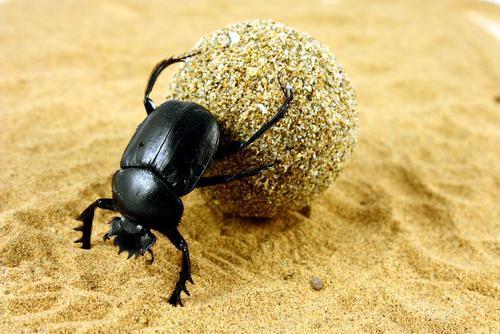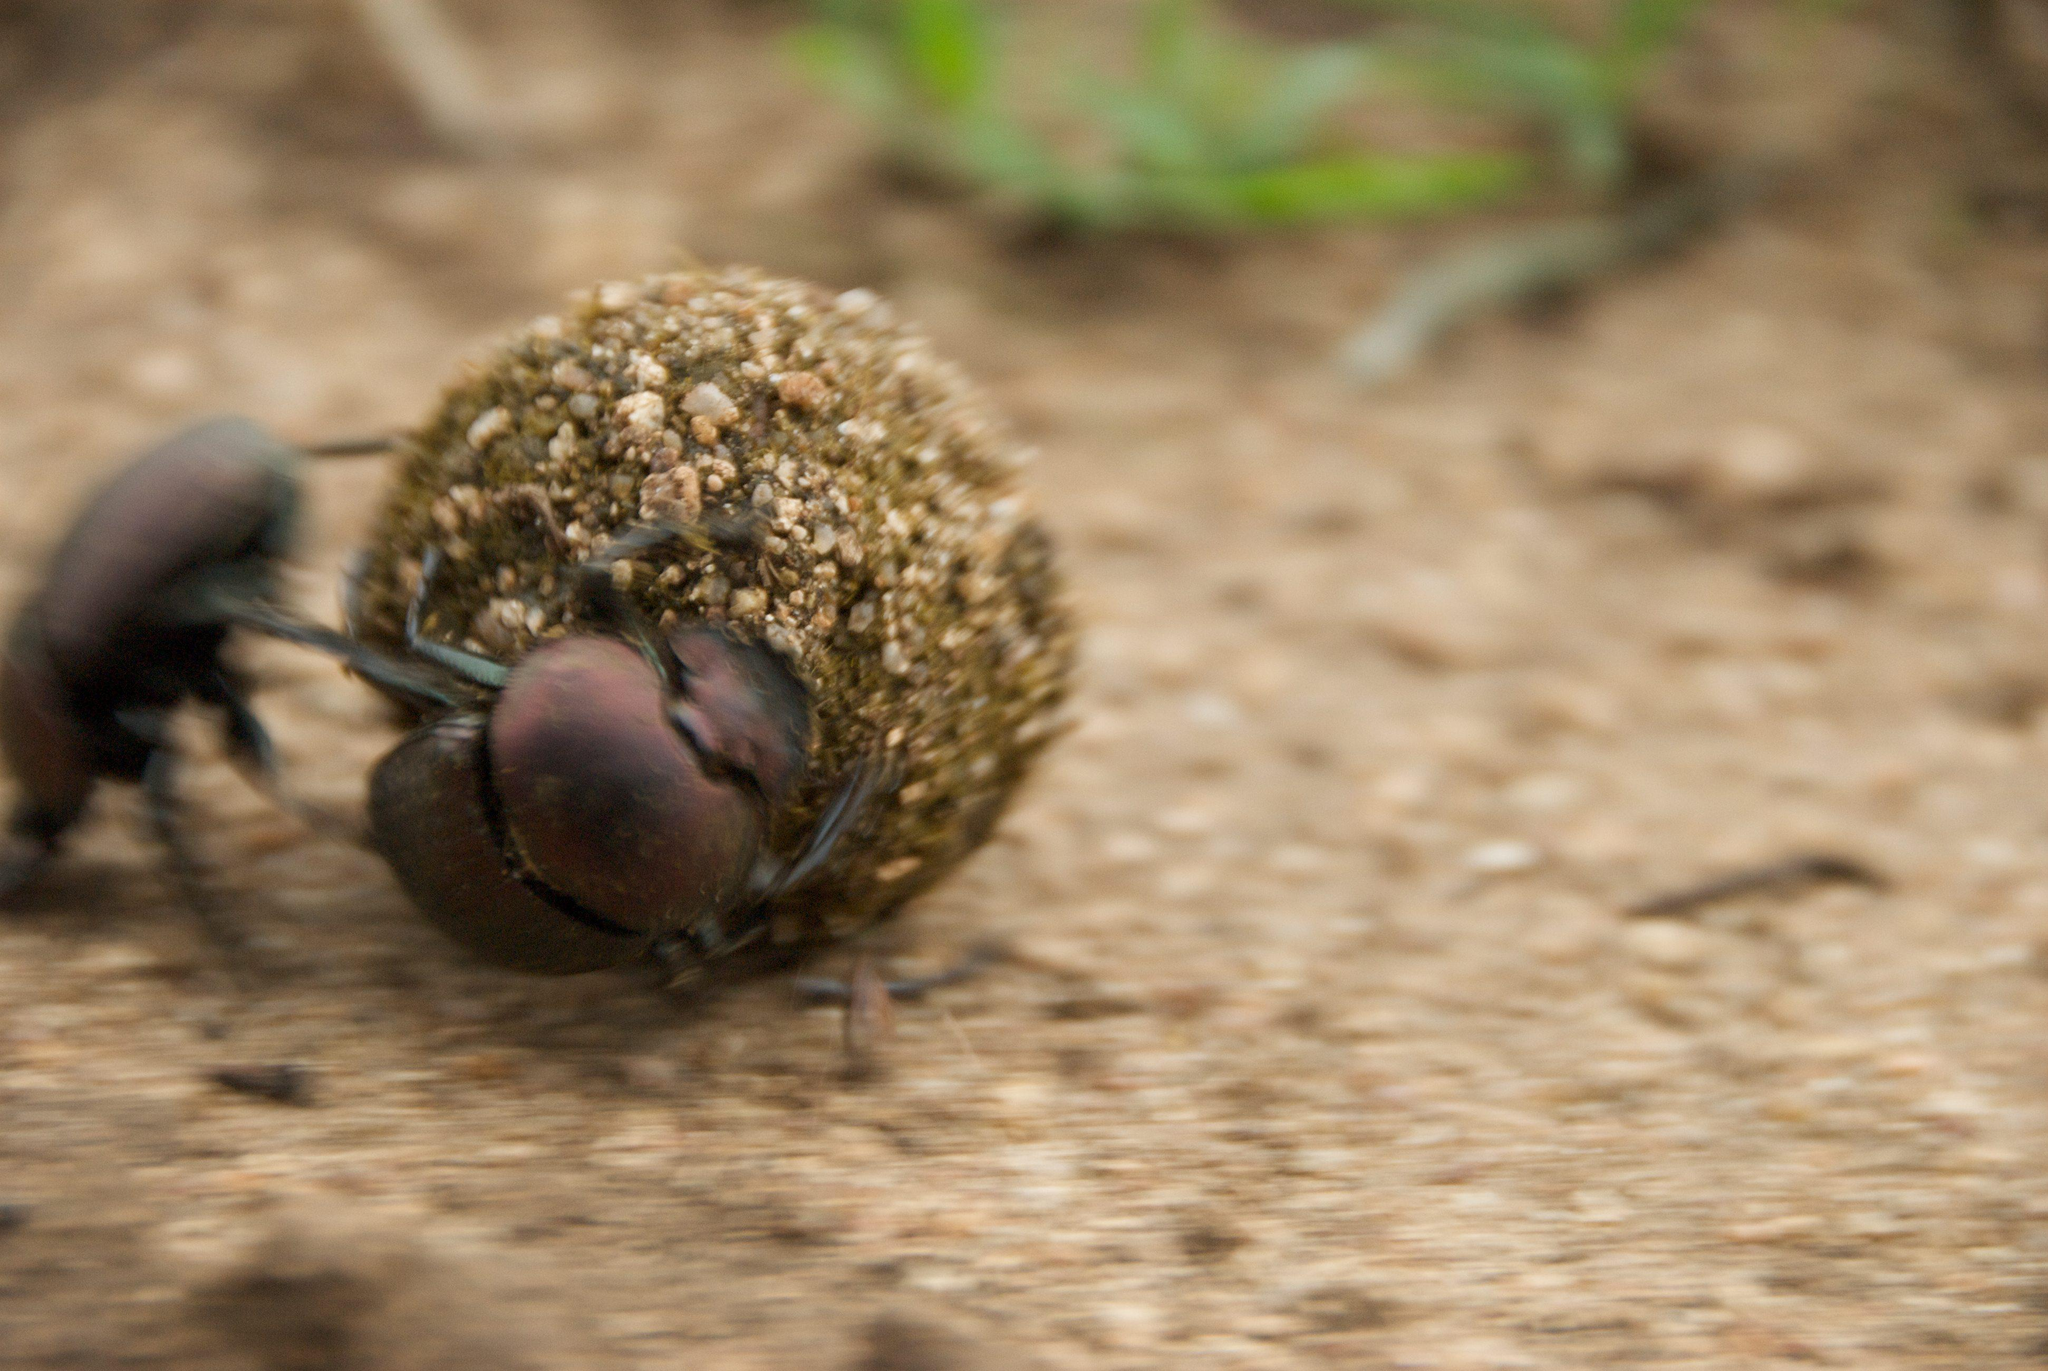The first image is the image on the left, the second image is the image on the right. Examine the images to the left and right. Is the description "An image shows a beetle without a dung ball." accurate? Answer yes or no. No. 